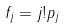Convert formula to latex. <formula><loc_0><loc_0><loc_500><loc_500>f _ { j } = j ! p _ { j }</formula> 